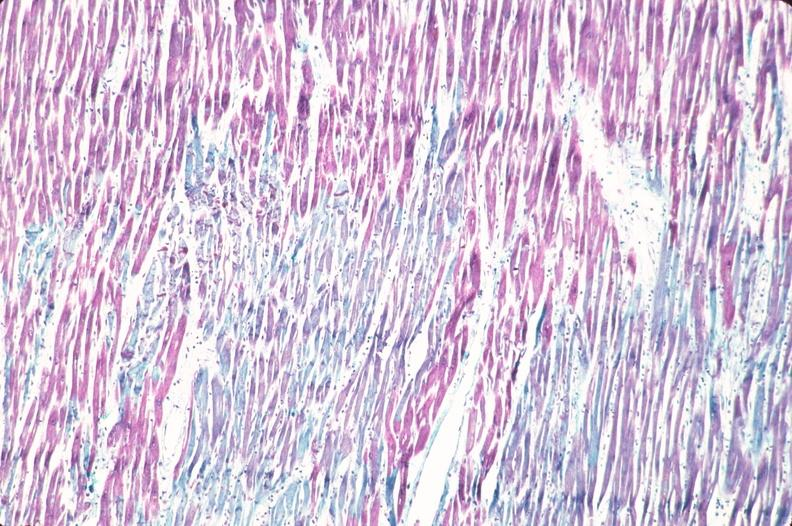where is this from?
Answer the question using a single word or phrase. Heart 